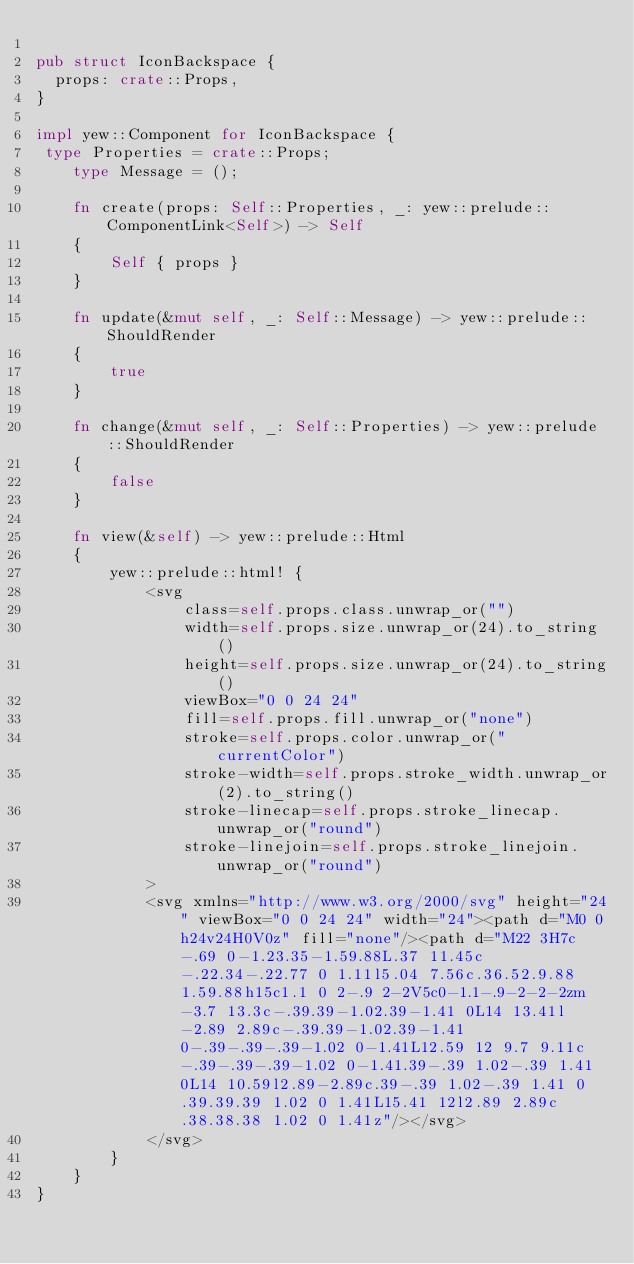<code> <loc_0><loc_0><loc_500><loc_500><_Rust_>
pub struct IconBackspace {
  props: crate::Props,
}

impl yew::Component for IconBackspace {
 type Properties = crate::Props;
    type Message = ();

    fn create(props: Self::Properties, _: yew::prelude::ComponentLink<Self>) -> Self
    {
        Self { props }
    }

    fn update(&mut self, _: Self::Message) -> yew::prelude::ShouldRender
    {
        true
    }

    fn change(&mut self, _: Self::Properties) -> yew::prelude::ShouldRender
    {
        false
    }

    fn view(&self) -> yew::prelude::Html
    {
        yew::prelude::html! {
            <svg
                class=self.props.class.unwrap_or("")
                width=self.props.size.unwrap_or(24).to_string()
                height=self.props.size.unwrap_or(24).to_string()
                viewBox="0 0 24 24"
                fill=self.props.fill.unwrap_or("none")
                stroke=self.props.color.unwrap_or("currentColor")
                stroke-width=self.props.stroke_width.unwrap_or(2).to_string()
                stroke-linecap=self.props.stroke_linecap.unwrap_or("round")
                stroke-linejoin=self.props.stroke_linejoin.unwrap_or("round")
            >
            <svg xmlns="http://www.w3.org/2000/svg" height="24" viewBox="0 0 24 24" width="24"><path d="M0 0h24v24H0V0z" fill="none"/><path d="M22 3H7c-.69 0-1.23.35-1.59.88L.37 11.45c-.22.34-.22.77 0 1.11l5.04 7.56c.36.52.9.88 1.59.88h15c1.1 0 2-.9 2-2V5c0-1.1-.9-2-2-2zm-3.7 13.3c-.39.39-1.02.39-1.41 0L14 13.41l-2.89 2.89c-.39.39-1.02.39-1.41 0-.39-.39-.39-1.02 0-1.41L12.59 12 9.7 9.11c-.39-.39-.39-1.02 0-1.41.39-.39 1.02-.39 1.41 0L14 10.59l2.89-2.89c.39-.39 1.02-.39 1.41 0 .39.39.39 1.02 0 1.41L15.41 12l2.89 2.89c.38.38.38 1.02 0 1.41z"/></svg>
            </svg>
        }
    }
}


</code> 